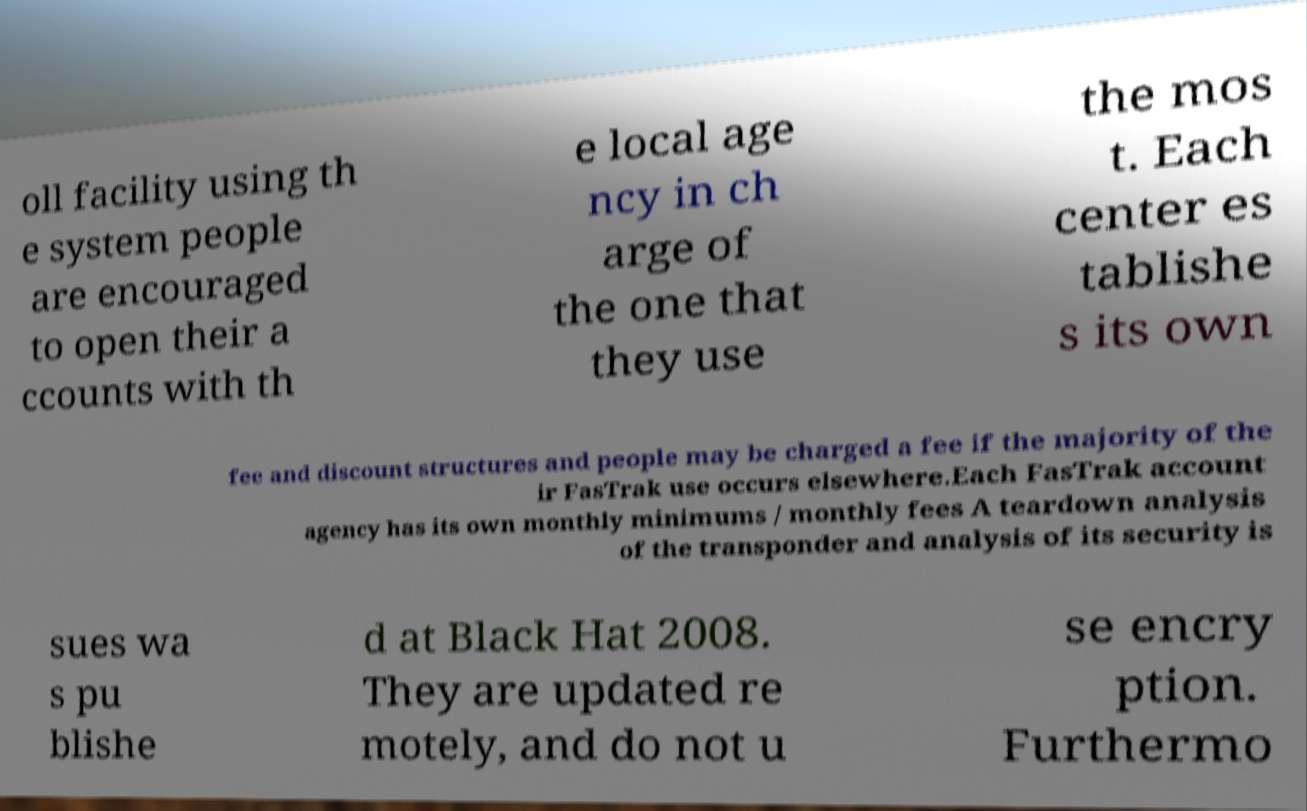For documentation purposes, I need the text within this image transcribed. Could you provide that? oll facility using th e system people are encouraged to open their a ccounts with th e local age ncy in ch arge of the one that they use the mos t. Each center es tablishe s its own fee and discount structures and people may be charged a fee if the majority of the ir FasTrak use occurs elsewhere.Each FasTrak account agency has its own monthly minimums / monthly fees A teardown analysis of the transponder and analysis of its security is sues wa s pu blishe d at Black Hat 2008. They are updated re motely, and do not u se encry ption. Furthermo 